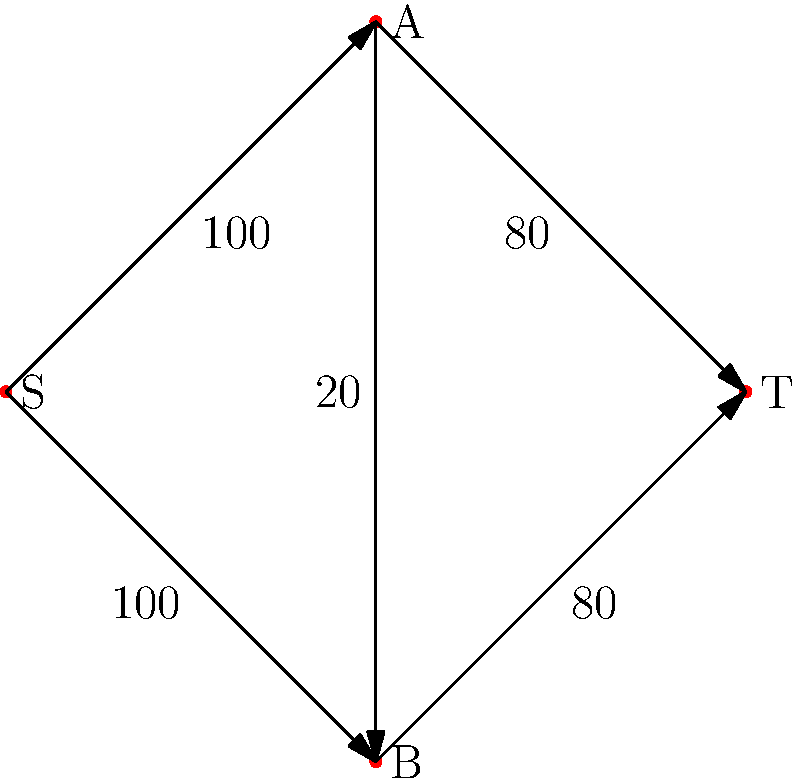In a network of Latin dance venues, the source (S) represents the entrance, the sink (T) represents the exit, and A and B are two popular dance floors. The edges represent pathways with capacities indicating the maximum number of dancers that can move through per hour. What is the maximum flow of dancers through this network? To solve this maximum flow problem, we'll use the Ford-Fulkerson algorithm:

1) Initialize flow to 0.

2) Find an augmenting path from S to T:
   Path 1: S -> A -> T (min capacity = 80)
   Augment flow by 80. New flow = 80.

3) Update residual graph and find another path:
   Path 2: S -> B -> T (min capacity = 80)
   Augment flow by 80. New flow = 160.

4) Update residual graph and find another path:
   Path 3: S -> A -> B -> T (min capacity = 20)
   Augment flow by 20. New flow = 180.

5) No more augmenting paths exist.

Therefore, the maximum flow is 180 dancers per hour.

This solution utilizes all available pathways:
- 100 dancers/hour from S to A (80 to T, 20 to B)
- 100 dancers/hour from S to B (80 directly to T, 20 from A)
- 80 dancers/hour from A to T
- 100 dancers/hour from B to T (80 directly, 20 from A)
Answer: 180 dancers per hour 